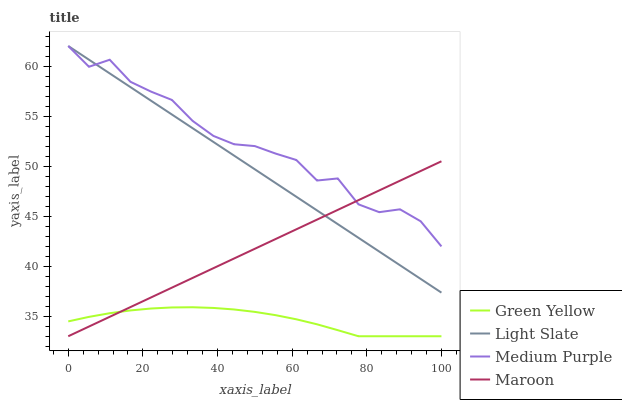Does Green Yellow have the minimum area under the curve?
Answer yes or no. Yes. Does Medium Purple have the maximum area under the curve?
Answer yes or no. Yes. Does Medium Purple have the minimum area under the curve?
Answer yes or no. No. Does Green Yellow have the maximum area under the curve?
Answer yes or no. No. Is Light Slate the smoothest?
Answer yes or no. Yes. Is Medium Purple the roughest?
Answer yes or no. Yes. Is Green Yellow the smoothest?
Answer yes or no. No. Is Green Yellow the roughest?
Answer yes or no. No. Does Medium Purple have the lowest value?
Answer yes or no. No. Does Medium Purple have the highest value?
Answer yes or no. Yes. Does Green Yellow have the highest value?
Answer yes or no. No. Is Green Yellow less than Medium Purple?
Answer yes or no. Yes. Is Light Slate greater than Green Yellow?
Answer yes or no. Yes. Does Maroon intersect Light Slate?
Answer yes or no. Yes. Is Maroon less than Light Slate?
Answer yes or no. No. Is Maroon greater than Light Slate?
Answer yes or no. No. Does Green Yellow intersect Medium Purple?
Answer yes or no. No. 